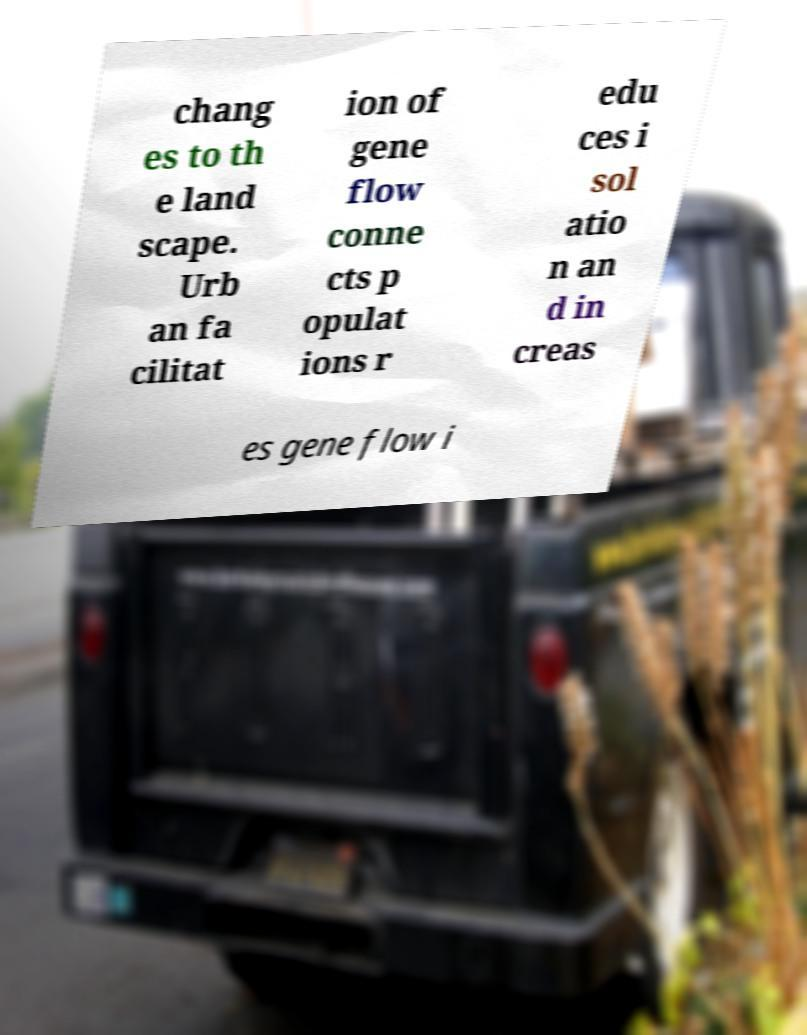Please identify and transcribe the text found in this image. chang es to th e land scape. Urb an fa cilitat ion of gene flow conne cts p opulat ions r edu ces i sol atio n an d in creas es gene flow i 